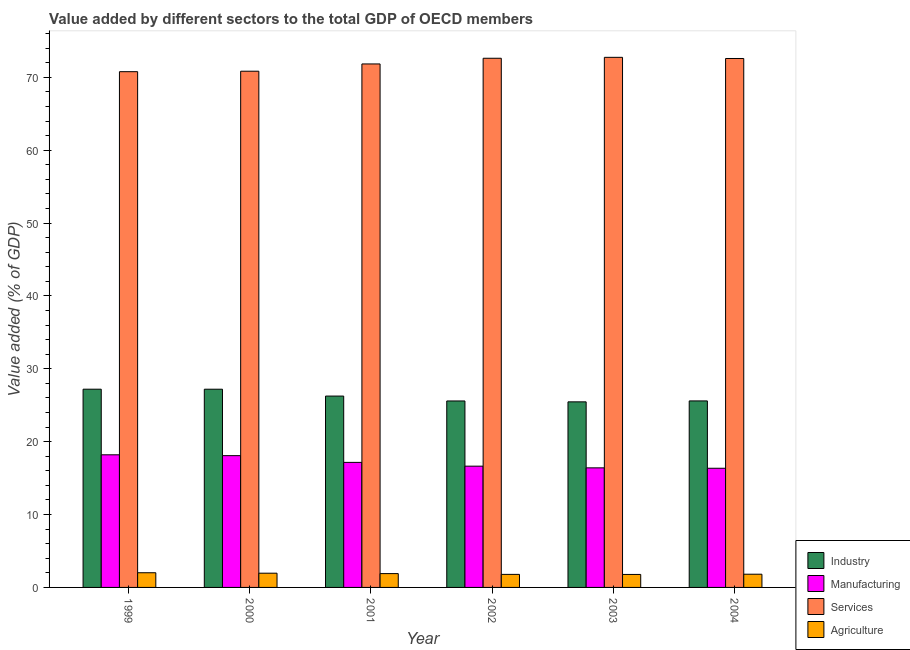How many different coloured bars are there?
Your answer should be compact. 4. How many groups of bars are there?
Keep it short and to the point. 6. What is the label of the 6th group of bars from the left?
Ensure brevity in your answer.  2004. In how many cases, is the number of bars for a given year not equal to the number of legend labels?
Offer a very short reply. 0. What is the value added by industrial sector in 2002?
Provide a succinct answer. 25.59. Across all years, what is the maximum value added by services sector?
Make the answer very short. 72.75. Across all years, what is the minimum value added by manufacturing sector?
Make the answer very short. 16.35. In which year was the value added by manufacturing sector maximum?
Offer a very short reply. 1999. In which year was the value added by agricultural sector minimum?
Give a very brief answer. 2003. What is the total value added by agricultural sector in the graph?
Give a very brief answer. 11.25. What is the difference between the value added by industrial sector in 1999 and that in 2000?
Your answer should be compact. 0. What is the difference between the value added by industrial sector in 2001 and the value added by manufacturing sector in 1999?
Your response must be concise. -0.94. What is the average value added by manufacturing sector per year?
Your answer should be compact. 17.14. In the year 2000, what is the difference between the value added by industrial sector and value added by agricultural sector?
Your response must be concise. 0. What is the ratio of the value added by manufacturing sector in 2003 to that in 2004?
Give a very brief answer. 1. Is the difference between the value added by agricultural sector in 2000 and 2001 greater than the difference between the value added by services sector in 2000 and 2001?
Offer a very short reply. No. What is the difference between the highest and the second highest value added by agricultural sector?
Provide a succinct answer. 0.06. What is the difference between the highest and the lowest value added by industrial sector?
Provide a succinct answer. 1.74. Is the sum of the value added by services sector in 2000 and 2003 greater than the maximum value added by industrial sector across all years?
Offer a terse response. Yes. Is it the case that in every year, the sum of the value added by services sector and value added by industrial sector is greater than the sum of value added by manufacturing sector and value added by agricultural sector?
Make the answer very short. Yes. What does the 2nd bar from the left in 2003 represents?
Offer a terse response. Manufacturing. What does the 3rd bar from the right in 2000 represents?
Provide a succinct answer. Manufacturing. How many years are there in the graph?
Offer a very short reply. 6. Are the values on the major ticks of Y-axis written in scientific E-notation?
Provide a succinct answer. No. Where does the legend appear in the graph?
Give a very brief answer. Bottom right. How many legend labels are there?
Make the answer very short. 4. What is the title of the graph?
Keep it short and to the point. Value added by different sectors to the total GDP of OECD members. What is the label or title of the X-axis?
Offer a terse response. Year. What is the label or title of the Y-axis?
Your response must be concise. Value added (% of GDP). What is the Value added (% of GDP) of Industry in 1999?
Your answer should be compact. 27.21. What is the Value added (% of GDP) of Manufacturing in 1999?
Your response must be concise. 18.2. What is the Value added (% of GDP) of Services in 1999?
Offer a terse response. 70.78. What is the Value added (% of GDP) of Agriculture in 1999?
Provide a short and direct response. 2.01. What is the Value added (% of GDP) in Industry in 2000?
Your answer should be compact. 27.2. What is the Value added (% of GDP) in Manufacturing in 2000?
Your response must be concise. 18.09. What is the Value added (% of GDP) of Services in 2000?
Your answer should be compact. 70.84. What is the Value added (% of GDP) in Agriculture in 2000?
Your response must be concise. 1.95. What is the Value added (% of GDP) of Industry in 2001?
Keep it short and to the point. 26.26. What is the Value added (% of GDP) in Manufacturing in 2001?
Ensure brevity in your answer.  17.16. What is the Value added (% of GDP) of Services in 2001?
Your answer should be very brief. 71.84. What is the Value added (% of GDP) of Agriculture in 2001?
Your response must be concise. 1.9. What is the Value added (% of GDP) in Industry in 2002?
Make the answer very short. 25.59. What is the Value added (% of GDP) in Manufacturing in 2002?
Make the answer very short. 16.64. What is the Value added (% of GDP) in Services in 2002?
Offer a very short reply. 72.62. What is the Value added (% of GDP) in Agriculture in 2002?
Ensure brevity in your answer.  1.79. What is the Value added (% of GDP) of Industry in 2003?
Give a very brief answer. 25.47. What is the Value added (% of GDP) in Manufacturing in 2003?
Provide a succinct answer. 16.41. What is the Value added (% of GDP) of Services in 2003?
Your response must be concise. 72.75. What is the Value added (% of GDP) of Agriculture in 2003?
Your answer should be very brief. 1.78. What is the Value added (% of GDP) of Industry in 2004?
Give a very brief answer. 25.6. What is the Value added (% of GDP) of Manufacturing in 2004?
Ensure brevity in your answer.  16.35. What is the Value added (% of GDP) of Services in 2004?
Your response must be concise. 72.59. What is the Value added (% of GDP) of Agriculture in 2004?
Your answer should be compact. 1.81. Across all years, what is the maximum Value added (% of GDP) of Industry?
Give a very brief answer. 27.21. Across all years, what is the maximum Value added (% of GDP) of Manufacturing?
Your answer should be very brief. 18.2. Across all years, what is the maximum Value added (% of GDP) of Services?
Provide a succinct answer. 72.75. Across all years, what is the maximum Value added (% of GDP) of Agriculture?
Offer a very short reply. 2.01. Across all years, what is the minimum Value added (% of GDP) in Industry?
Make the answer very short. 25.47. Across all years, what is the minimum Value added (% of GDP) in Manufacturing?
Your answer should be compact. 16.35. Across all years, what is the minimum Value added (% of GDP) of Services?
Keep it short and to the point. 70.78. Across all years, what is the minimum Value added (% of GDP) of Agriculture?
Offer a terse response. 1.78. What is the total Value added (% of GDP) in Industry in the graph?
Offer a very short reply. 157.32. What is the total Value added (% of GDP) of Manufacturing in the graph?
Your answer should be very brief. 102.85. What is the total Value added (% of GDP) of Services in the graph?
Your answer should be very brief. 431.42. What is the total Value added (% of GDP) of Agriculture in the graph?
Your answer should be very brief. 11.25. What is the difference between the Value added (% of GDP) of Industry in 1999 and that in 2000?
Provide a succinct answer. 0. What is the difference between the Value added (% of GDP) in Manufacturing in 1999 and that in 2000?
Keep it short and to the point. 0.12. What is the difference between the Value added (% of GDP) in Services in 1999 and that in 2000?
Your answer should be very brief. -0.06. What is the difference between the Value added (% of GDP) of Agriculture in 1999 and that in 2000?
Provide a succinct answer. 0.06. What is the difference between the Value added (% of GDP) in Industry in 1999 and that in 2001?
Offer a very short reply. 0.94. What is the difference between the Value added (% of GDP) in Manufacturing in 1999 and that in 2001?
Your answer should be compact. 1.04. What is the difference between the Value added (% of GDP) of Services in 1999 and that in 2001?
Keep it short and to the point. -1.06. What is the difference between the Value added (% of GDP) in Agriculture in 1999 and that in 2001?
Offer a very short reply. 0.12. What is the difference between the Value added (% of GDP) in Industry in 1999 and that in 2002?
Ensure brevity in your answer.  1.62. What is the difference between the Value added (% of GDP) of Manufacturing in 1999 and that in 2002?
Keep it short and to the point. 1.56. What is the difference between the Value added (% of GDP) in Services in 1999 and that in 2002?
Ensure brevity in your answer.  -1.84. What is the difference between the Value added (% of GDP) of Agriculture in 1999 and that in 2002?
Provide a succinct answer. 0.22. What is the difference between the Value added (% of GDP) in Industry in 1999 and that in 2003?
Provide a short and direct response. 1.74. What is the difference between the Value added (% of GDP) in Manufacturing in 1999 and that in 2003?
Your answer should be very brief. 1.79. What is the difference between the Value added (% of GDP) in Services in 1999 and that in 2003?
Provide a short and direct response. -1.97. What is the difference between the Value added (% of GDP) of Agriculture in 1999 and that in 2003?
Your response must be concise. 0.23. What is the difference between the Value added (% of GDP) in Industry in 1999 and that in 2004?
Offer a very short reply. 1.61. What is the difference between the Value added (% of GDP) in Manufacturing in 1999 and that in 2004?
Your answer should be compact. 1.85. What is the difference between the Value added (% of GDP) of Services in 1999 and that in 2004?
Offer a very short reply. -1.81. What is the difference between the Value added (% of GDP) of Agriculture in 1999 and that in 2004?
Offer a terse response. 0.2. What is the difference between the Value added (% of GDP) of Industry in 2000 and that in 2001?
Make the answer very short. 0.94. What is the difference between the Value added (% of GDP) in Manufacturing in 2000 and that in 2001?
Your answer should be very brief. 0.92. What is the difference between the Value added (% of GDP) in Services in 2000 and that in 2001?
Offer a terse response. -1. What is the difference between the Value added (% of GDP) of Agriculture in 2000 and that in 2001?
Offer a very short reply. 0.06. What is the difference between the Value added (% of GDP) in Industry in 2000 and that in 2002?
Give a very brief answer. 1.61. What is the difference between the Value added (% of GDP) in Manufacturing in 2000 and that in 2002?
Your answer should be compact. 1.44. What is the difference between the Value added (% of GDP) of Services in 2000 and that in 2002?
Offer a very short reply. -1.78. What is the difference between the Value added (% of GDP) in Agriculture in 2000 and that in 2002?
Provide a short and direct response. 0.16. What is the difference between the Value added (% of GDP) of Industry in 2000 and that in 2003?
Give a very brief answer. 1.73. What is the difference between the Value added (% of GDP) in Manufacturing in 2000 and that in 2003?
Keep it short and to the point. 1.67. What is the difference between the Value added (% of GDP) of Services in 2000 and that in 2003?
Your response must be concise. -1.9. What is the difference between the Value added (% of GDP) in Agriculture in 2000 and that in 2003?
Offer a very short reply. 0.17. What is the difference between the Value added (% of GDP) in Industry in 2000 and that in 2004?
Provide a succinct answer. 1.61. What is the difference between the Value added (% of GDP) of Manufacturing in 2000 and that in 2004?
Your answer should be very brief. 1.73. What is the difference between the Value added (% of GDP) in Services in 2000 and that in 2004?
Your answer should be very brief. -1.75. What is the difference between the Value added (% of GDP) in Agriculture in 2000 and that in 2004?
Give a very brief answer. 0.14. What is the difference between the Value added (% of GDP) in Industry in 2001 and that in 2002?
Give a very brief answer. 0.67. What is the difference between the Value added (% of GDP) of Manufacturing in 2001 and that in 2002?
Ensure brevity in your answer.  0.52. What is the difference between the Value added (% of GDP) of Services in 2001 and that in 2002?
Provide a succinct answer. -0.78. What is the difference between the Value added (% of GDP) of Agriculture in 2001 and that in 2002?
Offer a terse response. 0.11. What is the difference between the Value added (% of GDP) of Industry in 2001 and that in 2003?
Offer a terse response. 0.79. What is the difference between the Value added (% of GDP) of Manufacturing in 2001 and that in 2003?
Provide a short and direct response. 0.75. What is the difference between the Value added (% of GDP) of Services in 2001 and that in 2003?
Your answer should be very brief. -0.91. What is the difference between the Value added (% of GDP) in Agriculture in 2001 and that in 2003?
Provide a short and direct response. 0.12. What is the difference between the Value added (% of GDP) of Industry in 2001 and that in 2004?
Offer a very short reply. 0.67. What is the difference between the Value added (% of GDP) of Manufacturing in 2001 and that in 2004?
Provide a short and direct response. 0.81. What is the difference between the Value added (% of GDP) of Services in 2001 and that in 2004?
Your answer should be compact. -0.75. What is the difference between the Value added (% of GDP) in Agriculture in 2001 and that in 2004?
Ensure brevity in your answer.  0.08. What is the difference between the Value added (% of GDP) in Industry in 2002 and that in 2003?
Your answer should be compact. 0.12. What is the difference between the Value added (% of GDP) of Manufacturing in 2002 and that in 2003?
Your response must be concise. 0.23. What is the difference between the Value added (% of GDP) in Services in 2002 and that in 2003?
Keep it short and to the point. -0.13. What is the difference between the Value added (% of GDP) in Agriculture in 2002 and that in 2003?
Provide a succinct answer. 0.01. What is the difference between the Value added (% of GDP) of Industry in 2002 and that in 2004?
Ensure brevity in your answer.  -0.01. What is the difference between the Value added (% of GDP) in Manufacturing in 2002 and that in 2004?
Provide a succinct answer. 0.29. What is the difference between the Value added (% of GDP) in Services in 2002 and that in 2004?
Give a very brief answer. 0.03. What is the difference between the Value added (% of GDP) in Agriculture in 2002 and that in 2004?
Keep it short and to the point. -0.02. What is the difference between the Value added (% of GDP) of Industry in 2003 and that in 2004?
Provide a short and direct response. -0.13. What is the difference between the Value added (% of GDP) in Manufacturing in 2003 and that in 2004?
Ensure brevity in your answer.  0.06. What is the difference between the Value added (% of GDP) in Services in 2003 and that in 2004?
Offer a terse response. 0.16. What is the difference between the Value added (% of GDP) in Agriculture in 2003 and that in 2004?
Offer a terse response. -0.03. What is the difference between the Value added (% of GDP) in Industry in 1999 and the Value added (% of GDP) in Manufacturing in 2000?
Offer a terse response. 9.12. What is the difference between the Value added (% of GDP) in Industry in 1999 and the Value added (% of GDP) in Services in 2000?
Your response must be concise. -43.64. What is the difference between the Value added (% of GDP) in Industry in 1999 and the Value added (% of GDP) in Agriculture in 2000?
Provide a short and direct response. 25.25. What is the difference between the Value added (% of GDP) of Manufacturing in 1999 and the Value added (% of GDP) of Services in 2000?
Provide a short and direct response. -52.64. What is the difference between the Value added (% of GDP) in Manufacturing in 1999 and the Value added (% of GDP) in Agriculture in 2000?
Your answer should be compact. 16.25. What is the difference between the Value added (% of GDP) of Services in 1999 and the Value added (% of GDP) of Agriculture in 2000?
Your response must be concise. 68.83. What is the difference between the Value added (% of GDP) in Industry in 1999 and the Value added (% of GDP) in Manufacturing in 2001?
Keep it short and to the point. 10.04. What is the difference between the Value added (% of GDP) in Industry in 1999 and the Value added (% of GDP) in Services in 2001?
Ensure brevity in your answer.  -44.63. What is the difference between the Value added (% of GDP) of Industry in 1999 and the Value added (% of GDP) of Agriculture in 2001?
Keep it short and to the point. 25.31. What is the difference between the Value added (% of GDP) of Manufacturing in 1999 and the Value added (% of GDP) of Services in 2001?
Keep it short and to the point. -53.64. What is the difference between the Value added (% of GDP) of Manufacturing in 1999 and the Value added (% of GDP) of Agriculture in 2001?
Provide a short and direct response. 16.3. What is the difference between the Value added (% of GDP) of Services in 1999 and the Value added (% of GDP) of Agriculture in 2001?
Your answer should be compact. 68.88. What is the difference between the Value added (% of GDP) of Industry in 1999 and the Value added (% of GDP) of Manufacturing in 2002?
Your answer should be compact. 10.56. What is the difference between the Value added (% of GDP) in Industry in 1999 and the Value added (% of GDP) in Services in 2002?
Your response must be concise. -45.42. What is the difference between the Value added (% of GDP) of Industry in 1999 and the Value added (% of GDP) of Agriculture in 2002?
Keep it short and to the point. 25.41. What is the difference between the Value added (% of GDP) of Manufacturing in 1999 and the Value added (% of GDP) of Services in 2002?
Give a very brief answer. -54.42. What is the difference between the Value added (% of GDP) in Manufacturing in 1999 and the Value added (% of GDP) in Agriculture in 2002?
Offer a terse response. 16.41. What is the difference between the Value added (% of GDP) in Services in 1999 and the Value added (% of GDP) in Agriculture in 2002?
Your answer should be compact. 68.99. What is the difference between the Value added (% of GDP) of Industry in 1999 and the Value added (% of GDP) of Manufacturing in 2003?
Offer a terse response. 10.79. What is the difference between the Value added (% of GDP) in Industry in 1999 and the Value added (% of GDP) in Services in 2003?
Your answer should be very brief. -45.54. What is the difference between the Value added (% of GDP) of Industry in 1999 and the Value added (% of GDP) of Agriculture in 2003?
Ensure brevity in your answer.  25.42. What is the difference between the Value added (% of GDP) of Manufacturing in 1999 and the Value added (% of GDP) of Services in 2003?
Your answer should be very brief. -54.55. What is the difference between the Value added (% of GDP) in Manufacturing in 1999 and the Value added (% of GDP) in Agriculture in 2003?
Your answer should be very brief. 16.42. What is the difference between the Value added (% of GDP) in Services in 1999 and the Value added (% of GDP) in Agriculture in 2003?
Offer a very short reply. 69. What is the difference between the Value added (% of GDP) in Industry in 1999 and the Value added (% of GDP) in Manufacturing in 2004?
Provide a succinct answer. 10.85. What is the difference between the Value added (% of GDP) of Industry in 1999 and the Value added (% of GDP) of Services in 2004?
Offer a terse response. -45.38. What is the difference between the Value added (% of GDP) in Industry in 1999 and the Value added (% of GDP) in Agriculture in 2004?
Your response must be concise. 25.39. What is the difference between the Value added (% of GDP) in Manufacturing in 1999 and the Value added (% of GDP) in Services in 2004?
Provide a succinct answer. -54.39. What is the difference between the Value added (% of GDP) of Manufacturing in 1999 and the Value added (% of GDP) of Agriculture in 2004?
Give a very brief answer. 16.39. What is the difference between the Value added (% of GDP) of Services in 1999 and the Value added (% of GDP) of Agriculture in 2004?
Offer a terse response. 68.97. What is the difference between the Value added (% of GDP) of Industry in 2000 and the Value added (% of GDP) of Manufacturing in 2001?
Make the answer very short. 10.04. What is the difference between the Value added (% of GDP) of Industry in 2000 and the Value added (% of GDP) of Services in 2001?
Your answer should be very brief. -44.64. What is the difference between the Value added (% of GDP) of Industry in 2000 and the Value added (% of GDP) of Agriculture in 2001?
Keep it short and to the point. 25.3. What is the difference between the Value added (% of GDP) of Manufacturing in 2000 and the Value added (% of GDP) of Services in 2001?
Ensure brevity in your answer.  -53.75. What is the difference between the Value added (% of GDP) of Manufacturing in 2000 and the Value added (% of GDP) of Agriculture in 2001?
Your answer should be very brief. 16.19. What is the difference between the Value added (% of GDP) of Services in 2000 and the Value added (% of GDP) of Agriculture in 2001?
Ensure brevity in your answer.  68.95. What is the difference between the Value added (% of GDP) in Industry in 2000 and the Value added (% of GDP) in Manufacturing in 2002?
Your response must be concise. 10.56. What is the difference between the Value added (% of GDP) of Industry in 2000 and the Value added (% of GDP) of Services in 2002?
Your answer should be very brief. -45.42. What is the difference between the Value added (% of GDP) of Industry in 2000 and the Value added (% of GDP) of Agriculture in 2002?
Your answer should be very brief. 25.41. What is the difference between the Value added (% of GDP) of Manufacturing in 2000 and the Value added (% of GDP) of Services in 2002?
Offer a terse response. -54.54. What is the difference between the Value added (% of GDP) in Manufacturing in 2000 and the Value added (% of GDP) in Agriculture in 2002?
Your answer should be compact. 16.29. What is the difference between the Value added (% of GDP) in Services in 2000 and the Value added (% of GDP) in Agriculture in 2002?
Keep it short and to the point. 69.05. What is the difference between the Value added (% of GDP) in Industry in 2000 and the Value added (% of GDP) in Manufacturing in 2003?
Give a very brief answer. 10.79. What is the difference between the Value added (% of GDP) in Industry in 2000 and the Value added (% of GDP) in Services in 2003?
Make the answer very short. -45.55. What is the difference between the Value added (% of GDP) in Industry in 2000 and the Value added (% of GDP) in Agriculture in 2003?
Your answer should be compact. 25.42. What is the difference between the Value added (% of GDP) of Manufacturing in 2000 and the Value added (% of GDP) of Services in 2003?
Your answer should be very brief. -54.66. What is the difference between the Value added (% of GDP) of Manufacturing in 2000 and the Value added (% of GDP) of Agriculture in 2003?
Provide a succinct answer. 16.3. What is the difference between the Value added (% of GDP) of Services in 2000 and the Value added (% of GDP) of Agriculture in 2003?
Your answer should be compact. 69.06. What is the difference between the Value added (% of GDP) in Industry in 2000 and the Value added (% of GDP) in Manufacturing in 2004?
Your answer should be compact. 10.85. What is the difference between the Value added (% of GDP) of Industry in 2000 and the Value added (% of GDP) of Services in 2004?
Provide a short and direct response. -45.39. What is the difference between the Value added (% of GDP) in Industry in 2000 and the Value added (% of GDP) in Agriculture in 2004?
Provide a short and direct response. 25.39. What is the difference between the Value added (% of GDP) in Manufacturing in 2000 and the Value added (% of GDP) in Services in 2004?
Offer a terse response. -54.5. What is the difference between the Value added (% of GDP) in Manufacturing in 2000 and the Value added (% of GDP) in Agriculture in 2004?
Keep it short and to the point. 16.27. What is the difference between the Value added (% of GDP) in Services in 2000 and the Value added (% of GDP) in Agriculture in 2004?
Make the answer very short. 69.03. What is the difference between the Value added (% of GDP) in Industry in 2001 and the Value added (% of GDP) in Manufacturing in 2002?
Make the answer very short. 9.62. What is the difference between the Value added (% of GDP) in Industry in 2001 and the Value added (% of GDP) in Services in 2002?
Offer a terse response. -46.36. What is the difference between the Value added (% of GDP) in Industry in 2001 and the Value added (% of GDP) in Agriculture in 2002?
Your answer should be very brief. 24.47. What is the difference between the Value added (% of GDP) in Manufacturing in 2001 and the Value added (% of GDP) in Services in 2002?
Give a very brief answer. -55.46. What is the difference between the Value added (% of GDP) in Manufacturing in 2001 and the Value added (% of GDP) in Agriculture in 2002?
Your answer should be very brief. 15.37. What is the difference between the Value added (% of GDP) of Services in 2001 and the Value added (% of GDP) of Agriculture in 2002?
Your answer should be very brief. 70.05. What is the difference between the Value added (% of GDP) of Industry in 2001 and the Value added (% of GDP) of Manufacturing in 2003?
Your answer should be very brief. 9.85. What is the difference between the Value added (% of GDP) of Industry in 2001 and the Value added (% of GDP) of Services in 2003?
Ensure brevity in your answer.  -46.49. What is the difference between the Value added (% of GDP) of Industry in 2001 and the Value added (% of GDP) of Agriculture in 2003?
Give a very brief answer. 24.48. What is the difference between the Value added (% of GDP) of Manufacturing in 2001 and the Value added (% of GDP) of Services in 2003?
Your response must be concise. -55.59. What is the difference between the Value added (% of GDP) of Manufacturing in 2001 and the Value added (% of GDP) of Agriculture in 2003?
Ensure brevity in your answer.  15.38. What is the difference between the Value added (% of GDP) in Services in 2001 and the Value added (% of GDP) in Agriculture in 2003?
Offer a terse response. 70.06. What is the difference between the Value added (% of GDP) of Industry in 2001 and the Value added (% of GDP) of Manufacturing in 2004?
Keep it short and to the point. 9.91. What is the difference between the Value added (% of GDP) of Industry in 2001 and the Value added (% of GDP) of Services in 2004?
Keep it short and to the point. -46.33. What is the difference between the Value added (% of GDP) of Industry in 2001 and the Value added (% of GDP) of Agriculture in 2004?
Provide a short and direct response. 24.45. What is the difference between the Value added (% of GDP) of Manufacturing in 2001 and the Value added (% of GDP) of Services in 2004?
Your response must be concise. -55.43. What is the difference between the Value added (% of GDP) of Manufacturing in 2001 and the Value added (% of GDP) of Agriculture in 2004?
Provide a succinct answer. 15.35. What is the difference between the Value added (% of GDP) in Services in 2001 and the Value added (% of GDP) in Agriculture in 2004?
Your answer should be compact. 70.03. What is the difference between the Value added (% of GDP) in Industry in 2002 and the Value added (% of GDP) in Manufacturing in 2003?
Provide a succinct answer. 9.18. What is the difference between the Value added (% of GDP) of Industry in 2002 and the Value added (% of GDP) of Services in 2003?
Make the answer very short. -47.16. What is the difference between the Value added (% of GDP) in Industry in 2002 and the Value added (% of GDP) in Agriculture in 2003?
Give a very brief answer. 23.81. What is the difference between the Value added (% of GDP) of Manufacturing in 2002 and the Value added (% of GDP) of Services in 2003?
Give a very brief answer. -56.11. What is the difference between the Value added (% of GDP) of Manufacturing in 2002 and the Value added (% of GDP) of Agriculture in 2003?
Ensure brevity in your answer.  14.86. What is the difference between the Value added (% of GDP) in Services in 2002 and the Value added (% of GDP) in Agriculture in 2003?
Your answer should be very brief. 70.84. What is the difference between the Value added (% of GDP) in Industry in 2002 and the Value added (% of GDP) in Manufacturing in 2004?
Provide a succinct answer. 9.23. What is the difference between the Value added (% of GDP) of Industry in 2002 and the Value added (% of GDP) of Services in 2004?
Offer a terse response. -47. What is the difference between the Value added (% of GDP) of Industry in 2002 and the Value added (% of GDP) of Agriculture in 2004?
Make the answer very short. 23.77. What is the difference between the Value added (% of GDP) in Manufacturing in 2002 and the Value added (% of GDP) in Services in 2004?
Keep it short and to the point. -55.95. What is the difference between the Value added (% of GDP) in Manufacturing in 2002 and the Value added (% of GDP) in Agriculture in 2004?
Provide a succinct answer. 14.83. What is the difference between the Value added (% of GDP) of Services in 2002 and the Value added (% of GDP) of Agriculture in 2004?
Offer a very short reply. 70.81. What is the difference between the Value added (% of GDP) in Industry in 2003 and the Value added (% of GDP) in Manufacturing in 2004?
Offer a very short reply. 9.11. What is the difference between the Value added (% of GDP) in Industry in 2003 and the Value added (% of GDP) in Services in 2004?
Your response must be concise. -47.12. What is the difference between the Value added (% of GDP) of Industry in 2003 and the Value added (% of GDP) of Agriculture in 2004?
Offer a terse response. 23.65. What is the difference between the Value added (% of GDP) in Manufacturing in 2003 and the Value added (% of GDP) in Services in 2004?
Provide a short and direct response. -56.18. What is the difference between the Value added (% of GDP) of Manufacturing in 2003 and the Value added (% of GDP) of Agriculture in 2004?
Offer a terse response. 14.6. What is the difference between the Value added (% of GDP) of Services in 2003 and the Value added (% of GDP) of Agriculture in 2004?
Ensure brevity in your answer.  70.93. What is the average Value added (% of GDP) of Industry per year?
Make the answer very short. 26.22. What is the average Value added (% of GDP) in Manufacturing per year?
Keep it short and to the point. 17.14. What is the average Value added (% of GDP) in Services per year?
Ensure brevity in your answer.  71.9. What is the average Value added (% of GDP) in Agriculture per year?
Make the answer very short. 1.88. In the year 1999, what is the difference between the Value added (% of GDP) in Industry and Value added (% of GDP) in Manufacturing?
Your answer should be compact. 9. In the year 1999, what is the difference between the Value added (% of GDP) in Industry and Value added (% of GDP) in Services?
Your answer should be very brief. -43.57. In the year 1999, what is the difference between the Value added (% of GDP) of Industry and Value added (% of GDP) of Agriculture?
Give a very brief answer. 25.19. In the year 1999, what is the difference between the Value added (% of GDP) in Manufacturing and Value added (% of GDP) in Services?
Your answer should be compact. -52.58. In the year 1999, what is the difference between the Value added (% of GDP) of Manufacturing and Value added (% of GDP) of Agriculture?
Keep it short and to the point. 16.19. In the year 1999, what is the difference between the Value added (% of GDP) in Services and Value added (% of GDP) in Agriculture?
Give a very brief answer. 68.77. In the year 2000, what is the difference between the Value added (% of GDP) in Industry and Value added (% of GDP) in Manufacturing?
Your answer should be compact. 9.12. In the year 2000, what is the difference between the Value added (% of GDP) in Industry and Value added (% of GDP) in Services?
Make the answer very short. -43.64. In the year 2000, what is the difference between the Value added (% of GDP) in Industry and Value added (% of GDP) in Agriculture?
Your response must be concise. 25.25. In the year 2000, what is the difference between the Value added (% of GDP) in Manufacturing and Value added (% of GDP) in Services?
Offer a very short reply. -52.76. In the year 2000, what is the difference between the Value added (% of GDP) in Manufacturing and Value added (% of GDP) in Agriculture?
Your answer should be very brief. 16.13. In the year 2000, what is the difference between the Value added (% of GDP) of Services and Value added (% of GDP) of Agriculture?
Provide a succinct answer. 68.89. In the year 2001, what is the difference between the Value added (% of GDP) of Industry and Value added (% of GDP) of Manufacturing?
Offer a terse response. 9.1. In the year 2001, what is the difference between the Value added (% of GDP) in Industry and Value added (% of GDP) in Services?
Give a very brief answer. -45.58. In the year 2001, what is the difference between the Value added (% of GDP) of Industry and Value added (% of GDP) of Agriculture?
Ensure brevity in your answer.  24.36. In the year 2001, what is the difference between the Value added (% of GDP) of Manufacturing and Value added (% of GDP) of Services?
Offer a terse response. -54.68. In the year 2001, what is the difference between the Value added (% of GDP) of Manufacturing and Value added (% of GDP) of Agriculture?
Provide a succinct answer. 15.26. In the year 2001, what is the difference between the Value added (% of GDP) in Services and Value added (% of GDP) in Agriculture?
Offer a very short reply. 69.94. In the year 2002, what is the difference between the Value added (% of GDP) of Industry and Value added (% of GDP) of Manufacturing?
Offer a very short reply. 8.95. In the year 2002, what is the difference between the Value added (% of GDP) in Industry and Value added (% of GDP) in Services?
Your response must be concise. -47.03. In the year 2002, what is the difference between the Value added (% of GDP) in Industry and Value added (% of GDP) in Agriculture?
Make the answer very short. 23.8. In the year 2002, what is the difference between the Value added (% of GDP) in Manufacturing and Value added (% of GDP) in Services?
Give a very brief answer. -55.98. In the year 2002, what is the difference between the Value added (% of GDP) in Manufacturing and Value added (% of GDP) in Agriculture?
Your answer should be very brief. 14.85. In the year 2002, what is the difference between the Value added (% of GDP) in Services and Value added (% of GDP) in Agriculture?
Your answer should be very brief. 70.83. In the year 2003, what is the difference between the Value added (% of GDP) of Industry and Value added (% of GDP) of Manufacturing?
Give a very brief answer. 9.06. In the year 2003, what is the difference between the Value added (% of GDP) of Industry and Value added (% of GDP) of Services?
Your answer should be compact. -47.28. In the year 2003, what is the difference between the Value added (% of GDP) in Industry and Value added (% of GDP) in Agriculture?
Your answer should be very brief. 23.69. In the year 2003, what is the difference between the Value added (% of GDP) of Manufacturing and Value added (% of GDP) of Services?
Offer a very short reply. -56.34. In the year 2003, what is the difference between the Value added (% of GDP) in Manufacturing and Value added (% of GDP) in Agriculture?
Provide a succinct answer. 14.63. In the year 2003, what is the difference between the Value added (% of GDP) of Services and Value added (% of GDP) of Agriculture?
Provide a succinct answer. 70.97. In the year 2004, what is the difference between the Value added (% of GDP) of Industry and Value added (% of GDP) of Manufacturing?
Give a very brief answer. 9.24. In the year 2004, what is the difference between the Value added (% of GDP) in Industry and Value added (% of GDP) in Services?
Provide a short and direct response. -46.99. In the year 2004, what is the difference between the Value added (% of GDP) in Industry and Value added (% of GDP) in Agriculture?
Offer a terse response. 23.78. In the year 2004, what is the difference between the Value added (% of GDP) of Manufacturing and Value added (% of GDP) of Services?
Give a very brief answer. -56.23. In the year 2004, what is the difference between the Value added (% of GDP) in Manufacturing and Value added (% of GDP) in Agriculture?
Ensure brevity in your answer.  14.54. In the year 2004, what is the difference between the Value added (% of GDP) in Services and Value added (% of GDP) in Agriculture?
Offer a terse response. 70.78. What is the ratio of the Value added (% of GDP) in Industry in 1999 to that in 2000?
Make the answer very short. 1. What is the ratio of the Value added (% of GDP) of Manufacturing in 1999 to that in 2000?
Give a very brief answer. 1.01. What is the ratio of the Value added (% of GDP) of Agriculture in 1999 to that in 2000?
Offer a very short reply. 1.03. What is the ratio of the Value added (% of GDP) in Industry in 1999 to that in 2001?
Your response must be concise. 1.04. What is the ratio of the Value added (% of GDP) in Manufacturing in 1999 to that in 2001?
Keep it short and to the point. 1.06. What is the ratio of the Value added (% of GDP) in Services in 1999 to that in 2001?
Offer a very short reply. 0.99. What is the ratio of the Value added (% of GDP) in Agriculture in 1999 to that in 2001?
Provide a succinct answer. 1.06. What is the ratio of the Value added (% of GDP) of Industry in 1999 to that in 2002?
Provide a succinct answer. 1.06. What is the ratio of the Value added (% of GDP) in Manufacturing in 1999 to that in 2002?
Offer a very short reply. 1.09. What is the ratio of the Value added (% of GDP) in Services in 1999 to that in 2002?
Provide a succinct answer. 0.97. What is the ratio of the Value added (% of GDP) in Agriculture in 1999 to that in 2002?
Offer a terse response. 1.13. What is the ratio of the Value added (% of GDP) in Industry in 1999 to that in 2003?
Give a very brief answer. 1.07. What is the ratio of the Value added (% of GDP) of Manufacturing in 1999 to that in 2003?
Provide a short and direct response. 1.11. What is the ratio of the Value added (% of GDP) in Services in 1999 to that in 2003?
Offer a very short reply. 0.97. What is the ratio of the Value added (% of GDP) in Agriculture in 1999 to that in 2003?
Give a very brief answer. 1.13. What is the ratio of the Value added (% of GDP) in Industry in 1999 to that in 2004?
Your response must be concise. 1.06. What is the ratio of the Value added (% of GDP) of Manufacturing in 1999 to that in 2004?
Your answer should be compact. 1.11. What is the ratio of the Value added (% of GDP) of Services in 1999 to that in 2004?
Keep it short and to the point. 0.98. What is the ratio of the Value added (% of GDP) of Agriculture in 1999 to that in 2004?
Your answer should be compact. 1.11. What is the ratio of the Value added (% of GDP) of Industry in 2000 to that in 2001?
Make the answer very short. 1.04. What is the ratio of the Value added (% of GDP) in Manufacturing in 2000 to that in 2001?
Provide a short and direct response. 1.05. What is the ratio of the Value added (% of GDP) in Services in 2000 to that in 2001?
Offer a terse response. 0.99. What is the ratio of the Value added (% of GDP) of Agriculture in 2000 to that in 2001?
Your answer should be compact. 1.03. What is the ratio of the Value added (% of GDP) in Industry in 2000 to that in 2002?
Provide a succinct answer. 1.06. What is the ratio of the Value added (% of GDP) in Manufacturing in 2000 to that in 2002?
Provide a short and direct response. 1.09. What is the ratio of the Value added (% of GDP) in Services in 2000 to that in 2002?
Make the answer very short. 0.98. What is the ratio of the Value added (% of GDP) in Agriculture in 2000 to that in 2002?
Your response must be concise. 1.09. What is the ratio of the Value added (% of GDP) in Industry in 2000 to that in 2003?
Offer a very short reply. 1.07. What is the ratio of the Value added (% of GDP) of Manufacturing in 2000 to that in 2003?
Offer a very short reply. 1.1. What is the ratio of the Value added (% of GDP) of Services in 2000 to that in 2003?
Your answer should be very brief. 0.97. What is the ratio of the Value added (% of GDP) of Agriculture in 2000 to that in 2003?
Provide a short and direct response. 1.1. What is the ratio of the Value added (% of GDP) of Industry in 2000 to that in 2004?
Your response must be concise. 1.06. What is the ratio of the Value added (% of GDP) of Manufacturing in 2000 to that in 2004?
Provide a succinct answer. 1.11. What is the ratio of the Value added (% of GDP) of Services in 2000 to that in 2004?
Keep it short and to the point. 0.98. What is the ratio of the Value added (% of GDP) in Agriculture in 2000 to that in 2004?
Give a very brief answer. 1.08. What is the ratio of the Value added (% of GDP) of Industry in 2001 to that in 2002?
Give a very brief answer. 1.03. What is the ratio of the Value added (% of GDP) of Manufacturing in 2001 to that in 2002?
Offer a terse response. 1.03. What is the ratio of the Value added (% of GDP) of Services in 2001 to that in 2002?
Your answer should be compact. 0.99. What is the ratio of the Value added (% of GDP) in Agriculture in 2001 to that in 2002?
Provide a short and direct response. 1.06. What is the ratio of the Value added (% of GDP) of Industry in 2001 to that in 2003?
Offer a very short reply. 1.03. What is the ratio of the Value added (% of GDP) of Manufacturing in 2001 to that in 2003?
Provide a short and direct response. 1.05. What is the ratio of the Value added (% of GDP) in Services in 2001 to that in 2003?
Your response must be concise. 0.99. What is the ratio of the Value added (% of GDP) in Agriculture in 2001 to that in 2003?
Provide a short and direct response. 1.07. What is the ratio of the Value added (% of GDP) of Industry in 2001 to that in 2004?
Your answer should be very brief. 1.03. What is the ratio of the Value added (% of GDP) of Manufacturing in 2001 to that in 2004?
Offer a very short reply. 1.05. What is the ratio of the Value added (% of GDP) of Services in 2001 to that in 2004?
Keep it short and to the point. 0.99. What is the ratio of the Value added (% of GDP) in Agriculture in 2001 to that in 2004?
Keep it short and to the point. 1.05. What is the ratio of the Value added (% of GDP) of Industry in 2002 to that in 2003?
Provide a succinct answer. 1. What is the ratio of the Value added (% of GDP) of Manufacturing in 2002 to that in 2003?
Provide a short and direct response. 1.01. What is the ratio of the Value added (% of GDP) of Services in 2002 to that in 2003?
Keep it short and to the point. 1. What is the ratio of the Value added (% of GDP) in Agriculture in 2002 to that in 2003?
Provide a succinct answer. 1. What is the ratio of the Value added (% of GDP) of Industry in 2002 to that in 2004?
Provide a short and direct response. 1. What is the ratio of the Value added (% of GDP) of Manufacturing in 2002 to that in 2004?
Provide a succinct answer. 1.02. What is the ratio of the Value added (% of GDP) in Agriculture in 2002 to that in 2004?
Keep it short and to the point. 0.99. What is the ratio of the Value added (% of GDP) of Manufacturing in 2003 to that in 2004?
Offer a terse response. 1. What is the ratio of the Value added (% of GDP) in Agriculture in 2003 to that in 2004?
Your response must be concise. 0.98. What is the difference between the highest and the second highest Value added (% of GDP) in Industry?
Make the answer very short. 0. What is the difference between the highest and the second highest Value added (% of GDP) in Manufacturing?
Make the answer very short. 0.12. What is the difference between the highest and the second highest Value added (% of GDP) of Services?
Offer a terse response. 0.13. What is the difference between the highest and the second highest Value added (% of GDP) in Agriculture?
Keep it short and to the point. 0.06. What is the difference between the highest and the lowest Value added (% of GDP) of Industry?
Your response must be concise. 1.74. What is the difference between the highest and the lowest Value added (% of GDP) in Manufacturing?
Your answer should be very brief. 1.85. What is the difference between the highest and the lowest Value added (% of GDP) of Services?
Your response must be concise. 1.97. What is the difference between the highest and the lowest Value added (% of GDP) of Agriculture?
Give a very brief answer. 0.23. 